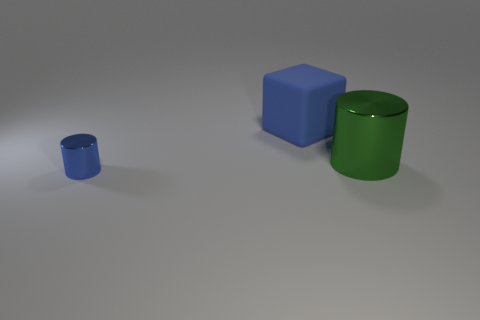Add 1 large green cylinders. How many objects exist? 4 Subtract all cubes. How many objects are left? 2 Subtract all blue rubber objects. Subtract all rubber things. How many objects are left? 1 Add 2 small blue shiny cylinders. How many small blue shiny cylinders are left? 3 Add 1 yellow rubber things. How many yellow rubber things exist? 1 Subtract 0 brown cylinders. How many objects are left? 3 